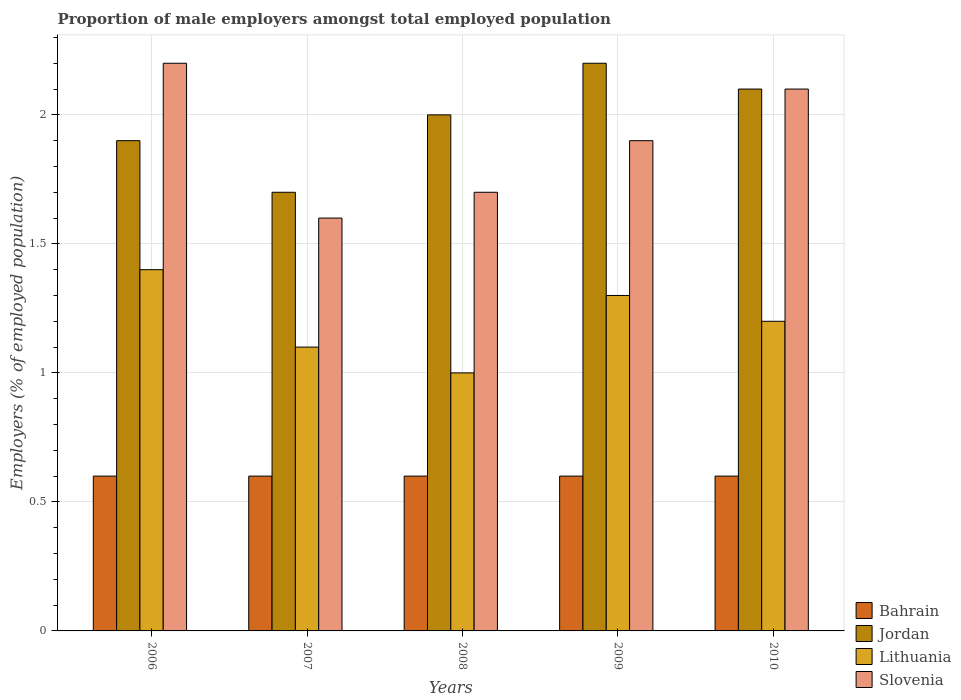How many bars are there on the 4th tick from the left?
Keep it short and to the point. 4. How many bars are there on the 3rd tick from the right?
Your response must be concise. 4. What is the proportion of male employers in Lithuania in 2006?
Give a very brief answer. 1.4. Across all years, what is the maximum proportion of male employers in Jordan?
Your answer should be compact. 2.2. Across all years, what is the minimum proportion of male employers in Slovenia?
Offer a terse response. 1.6. In which year was the proportion of male employers in Bahrain maximum?
Provide a short and direct response. 2006. What is the difference between the proportion of male employers in Slovenia in 2007 and that in 2009?
Offer a terse response. -0.3. What is the difference between the proportion of male employers in Slovenia in 2008 and the proportion of male employers in Lithuania in 2009?
Provide a succinct answer. 0.4. What is the average proportion of male employers in Slovenia per year?
Offer a terse response. 1.9. In the year 2010, what is the difference between the proportion of male employers in Lithuania and proportion of male employers in Bahrain?
Ensure brevity in your answer.  0.6. In how many years, is the proportion of male employers in Bahrain greater than 2.2 %?
Offer a terse response. 0. Is the proportion of male employers in Slovenia in 2006 less than that in 2009?
Your response must be concise. No. Is the difference between the proportion of male employers in Lithuania in 2006 and 2007 greater than the difference between the proportion of male employers in Bahrain in 2006 and 2007?
Your response must be concise. Yes. What is the difference between the highest and the lowest proportion of male employers in Bahrain?
Keep it short and to the point. 0. In how many years, is the proportion of male employers in Lithuania greater than the average proportion of male employers in Lithuania taken over all years?
Your answer should be compact. 3. What does the 4th bar from the left in 2006 represents?
Provide a short and direct response. Slovenia. What does the 3rd bar from the right in 2008 represents?
Provide a short and direct response. Jordan. Are all the bars in the graph horizontal?
Ensure brevity in your answer.  No. How many years are there in the graph?
Provide a short and direct response. 5. What is the difference between two consecutive major ticks on the Y-axis?
Provide a succinct answer. 0.5. Does the graph contain any zero values?
Make the answer very short. No. Does the graph contain grids?
Give a very brief answer. Yes. Where does the legend appear in the graph?
Offer a very short reply. Bottom right. How many legend labels are there?
Your response must be concise. 4. How are the legend labels stacked?
Make the answer very short. Vertical. What is the title of the graph?
Make the answer very short. Proportion of male employers amongst total employed population. What is the label or title of the Y-axis?
Your answer should be compact. Employers (% of employed population). What is the Employers (% of employed population) of Bahrain in 2006?
Offer a very short reply. 0.6. What is the Employers (% of employed population) in Jordan in 2006?
Your response must be concise. 1.9. What is the Employers (% of employed population) of Lithuania in 2006?
Offer a very short reply. 1.4. What is the Employers (% of employed population) of Slovenia in 2006?
Keep it short and to the point. 2.2. What is the Employers (% of employed population) of Bahrain in 2007?
Your response must be concise. 0.6. What is the Employers (% of employed population) in Jordan in 2007?
Provide a short and direct response. 1.7. What is the Employers (% of employed population) in Lithuania in 2007?
Provide a short and direct response. 1.1. What is the Employers (% of employed population) in Slovenia in 2007?
Provide a short and direct response. 1.6. What is the Employers (% of employed population) in Bahrain in 2008?
Offer a terse response. 0.6. What is the Employers (% of employed population) in Jordan in 2008?
Give a very brief answer. 2. What is the Employers (% of employed population) in Lithuania in 2008?
Make the answer very short. 1. What is the Employers (% of employed population) in Slovenia in 2008?
Provide a succinct answer. 1.7. What is the Employers (% of employed population) in Bahrain in 2009?
Offer a very short reply. 0.6. What is the Employers (% of employed population) in Jordan in 2009?
Provide a short and direct response. 2.2. What is the Employers (% of employed population) of Lithuania in 2009?
Keep it short and to the point. 1.3. What is the Employers (% of employed population) of Slovenia in 2009?
Provide a short and direct response. 1.9. What is the Employers (% of employed population) in Bahrain in 2010?
Ensure brevity in your answer.  0.6. What is the Employers (% of employed population) of Jordan in 2010?
Your response must be concise. 2.1. What is the Employers (% of employed population) of Lithuania in 2010?
Give a very brief answer. 1.2. What is the Employers (% of employed population) of Slovenia in 2010?
Provide a short and direct response. 2.1. Across all years, what is the maximum Employers (% of employed population) of Bahrain?
Provide a succinct answer. 0.6. Across all years, what is the maximum Employers (% of employed population) of Jordan?
Keep it short and to the point. 2.2. Across all years, what is the maximum Employers (% of employed population) in Lithuania?
Provide a short and direct response. 1.4. Across all years, what is the maximum Employers (% of employed population) in Slovenia?
Your answer should be compact. 2.2. Across all years, what is the minimum Employers (% of employed population) in Bahrain?
Ensure brevity in your answer.  0.6. Across all years, what is the minimum Employers (% of employed population) of Jordan?
Your answer should be very brief. 1.7. Across all years, what is the minimum Employers (% of employed population) of Lithuania?
Give a very brief answer. 1. Across all years, what is the minimum Employers (% of employed population) in Slovenia?
Keep it short and to the point. 1.6. What is the total Employers (% of employed population) of Jordan in the graph?
Give a very brief answer. 9.9. What is the total Employers (% of employed population) of Lithuania in the graph?
Offer a very short reply. 6. What is the total Employers (% of employed population) in Slovenia in the graph?
Provide a short and direct response. 9.5. What is the difference between the Employers (% of employed population) in Bahrain in 2006 and that in 2007?
Make the answer very short. 0. What is the difference between the Employers (% of employed population) of Bahrain in 2006 and that in 2008?
Offer a terse response. 0. What is the difference between the Employers (% of employed population) in Lithuania in 2006 and that in 2008?
Provide a succinct answer. 0.4. What is the difference between the Employers (% of employed population) of Slovenia in 2006 and that in 2008?
Offer a very short reply. 0.5. What is the difference between the Employers (% of employed population) in Jordan in 2006 and that in 2009?
Offer a very short reply. -0.3. What is the difference between the Employers (% of employed population) of Slovenia in 2006 and that in 2009?
Provide a short and direct response. 0.3. What is the difference between the Employers (% of employed population) in Jordan in 2006 and that in 2010?
Your answer should be compact. -0.2. What is the difference between the Employers (% of employed population) in Lithuania in 2006 and that in 2010?
Provide a short and direct response. 0.2. What is the difference between the Employers (% of employed population) in Slovenia in 2006 and that in 2010?
Your answer should be very brief. 0.1. What is the difference between the Employers (% of employed population) in Bahrain in 2007 and that in 2009?
Make the answer very short. 0. What is the difference between the Employers (% of employed population) of Jordan in 2007 and that in 2009?
Give a very brief answer. -0.5. What is the difference between the Employers (% of employed population) of Bahrain in 2007 and that in 2010?
Your answer should be compact. 0. What is the difference between the Employers (% of employed population) of Jordan in 2007 and that in 2010?
Your answer should be compact. -0.4. What is the difference between the Employers (% of employed population) of Slovenia in 2007 and that in 2010?
Give a very brief answer. -0.5. What is the difference between the Employers (% of employed population) in Bahrain in 2008 and that in 2009?
Make the answer very short. 0. What is the difference between the Employers (% of employed population) of Jordan in 2008 and that in 2009?
Make the answer very short. -0.2. What is the difference between the Employers (% of employed population) of Slovenia in 2008 and that in 2009?
Make the answer very short. -0.2. What is the difference between the Employers (% of employed population) in Jordan in 2008 and that in 2010?
Offer a very short reply. -0.1. What is the difference between the Employers (% of employed population) in Lithuania in 2008 and that in 2010?
Make the answer very short. -0.2. What is the difference between the Employers (% of employed population) of Slovenia in 2008 and that in 2010?
Make the answer very short. -0.4. What is the difference between the Employers (% of employed population) of Bahrain in 2009 and that in 2010?
Offer a very short reply. 0. What is the difference between the Employers (% of employed population) in Lithuania in 2009 and that in 2010?
Keep it short and to the point. 0.1. What is the difference between the Employers (% of employed population) of Bahrain in 2006 and the Employers (% of employed population) of Lithuania in 2007?
Your answer should be compact. -0.5. What is the difference between the Employers (% of employed population) of Bahrain in 2006 and the Employers (% of employed population) of Slovenia in 2007?
Provide a succinct answer. -1. What is the difference between the Employers (% of employed population) in Jordan in 2006 and the Employers (% of employed population) in Lithuania in 2007?
Make the answer very short. 0.8. What is the difference between the Employers (% of employed population) of Jordan in 2006 and the Employers (% of employed population) of Slovenia in 2007?
Your answer should be compact. 0.3. What is the difference between the Employers (% of employed population) of Bahrain in 2006 and the Employers (% of employed population) of Jordan in 2008?
Provide a short and direct response. -1.4. What is the difference between the Employers (% of employed population) of Jordan in 2006 and the Employers (% of employed population) of Lithuania in 2008?
Give a very brief answer. 0.9. What is the difference between the Employers (% of employed population) in Jordan in 2006 and the Employers (% of employed population) in Slovenia in 2008?
Your response must be concise. 0.2. What is the difference between the Employers (% of employed population) of Bahrain in 2006 and the Employers (% of employed population) of Slovenia in 2009?
Keep it short and to the point. -1.3. What is the difference between the Employers (% of employed population) of Jordan in 2006 and the Employers (% of employed population) of Lithuania in 2009?
Your answer should be very brief. 0.6. What is the difference between the Employers (% of employed population) of Jordan in 2006 and the Employers (% of employed population) of Slovenia in 2009?
Your response must be concise. 0. What is the difference between the Employers (% of employed population) in Bahrain in 2006 and the Employers (% of employed population) in Jordan in 2010?
Offer a terse response. -1.5. What is the difference between the Employers (% of employed population) in Bahrain in 2006 and the Employers (% of employed population) in Lithuania in 2010?
Your answer should be very brief. -0.6. What is the difference between the Employers (% of employed population) in Bahrain in 2007 and the Employers (% of employed population) in Jordan in 2008?
Make the answer very short. -1.4. What is the difference between the Employers (% of employed population) of Jordan in 2007 and the Employers (% of employed population) of Slovenia in 2008?
Ensure brevity in your answer.  0. What is the difference between the Employers (% of employed population) in Bahrain in 2007 and the Employers (% of employed population) in Slovenia in 2009?
Offer a very short reply. -1.3. What is the difference between the Employers (% of employed population) in Bahrain in 2007 and the Employers (% of employed population) in Jordan in 2010?
Provide a succinct answer. -1.5. What is the difference between the Employers (% of employed population) of Bahrain in 2007 and the Employers (% of employed population) of Lithuania in 2010?
Offer a terse response. -0.6. What is the difference between the Employers (% of employed population) in Bahrain in 2007 and the Employers (% of employed population) in Slovenia in 2010?
Give a very brief answer. -1.5. What is the difference between the Employers (% of employed population) of Jordan in 2007 and the Employers (% of employed population) of Lithuania in 2010?
Ensure brevity in your answer.  0.5. What is the difference between the Employers (% of employed population) of Lithuania in 2007 and the Employers (% of employed population) of Slovenia in 2010?
Keep it short and to the point. -1. What is the difference between the Employers (% of employed population) in Bahrain in 2008 and the Employers (% of employed population) in Slovenia in 2009?
Your answer should be very brief. -1.3. What is the difference between the Employers (% of employed population) of Jordan in 2008 and the Employers (% of employed population) of Lithuania in 2009?
Your answer should be very brief. 0.7. What is the difference between the Employers (% of employed population) in Jordan in 2008 and the Employers (% of employed population) in Slovenia in 2009?
Give a very brief answer. 0.1. What is the difference between the Employers (% of employed population) of Bahrain in 2008 and the Employers (% of employed population) of Jordan in 2010?
Offer a terse response. -1.5. What is the difference between the Employers (% of employed population) of Bahrain in 2008 and the Employers (% of employed population) of Slovenia in 2010?
Your response must be concise. -1.5. What is the difference between the Employers (% of employed population) in Jordan in 2008 and the Employers (% of employed population) in Slovenia in 2010?
Provide a short and direct response. -0.1. What is the difference between the Employers (% of employed population) in Lithuania in 2008 and the Employers (% of employed population) in Slovenia in 2010?
Offer a very short reply. -1.1. What is the difference between the Employers (% of employed population) of Bahrain in 2009 and the Employers (% of employed population) of Jordan in 2010?
Provide a succinct answer. -1.5. What is the difference between the Employers (% of employed population) of Bahrain in 2009 and the Employers (% of employed population) of Slovenia in 2010?
Provide a succinct answer. -1.5. What is the difference between the Employers (% of employed population) in Jordan in 2009 and the Employers (% of employed population) in Lithuania in 2010?
Your answer should be very brief. 1. What is the difference between the Employers (% of employed population) in Jordan in 2009 and the Employers (% of employed population) in Slovenia in 2010?
Provide a short and direct response. 0.1. What is the average Employers (% of employed population) of Bahrain per year?
Keep it short and to the point. 0.6. What is the average Employers (% of employed population) in Jordan per year?
Make the answer very short. 1.98. In the year 2006, what is the difference between the Employers (% of employed population) in Bahrain and Employers (% of employed population) in Lithuania?
Provide a succinct answer. -0.8. In the year 2006, what is the difference between the Employers (% of employed population) in Bahrain and Employers (% of employed population) in Slovenia?
Keep it short and to the point. -1.6. In the year 2006, what is the difference between the Employers (% of employed population) in Jordan and Employers (% of employed population) in Slovenia?
Your answer should be very brief. -0.3. In the year 2007, what is the difference between the Employers (% of employed population) of Bahrain and Employers (% of employed population) of Lithuania?
Give a very brief answer. -0.5. In the year 2007, what is the difference between the Employers (% of employed population) of Jordan and Employers (% of employed population) of Slovenia?
Keep it short and to the point. 0.1. In the year 2008, what is the difference between the Employers (% of employed population) in Bahrain and Employers (% of employed population) in Jordan?
Provide a short and direct response. -1.4. In the year 2008, what is the difference between the Employers (% of employed population) in Bahrain and Employers (% of employed population) in Lithuania?
Offer a terse response. -0.4. In the year 2008, what is the difference between the Employers (% of employed population) of Lithuania and Employers (% of employed population) of Slovenia?
Keep it short and to the point. -0.7. In the year 2009, what is the difference between the Employers (% of employed population) in Bahrain and Employers (% of employed population) in Lithuania?
Offer a terse response. -0.7. In the year 2009, what is the difference between the Employers (% of employed population) of Bahrain and Employers (% of employed population) of Slovenia?
Offer a terse response. -1.3. In the year 2009, what is the difference between the Employers (% of employed population) of Lithuania and Employers (% of employed population) of Slovenia?
Ensure brevity in your answer.  -0.6. In the year 2010, what is the difference between the Employers (% of employed population) in Bahrain and Employers (% of employed population) in Lithuania?
Ensure brevity in your answer.  -0.6. In the year 2010, what is the difference between the Employers (% of employed population) in Bahrain and Employers (% of employed population) in Slovenia?
Give a very brief answer. -1.5. In the year 2010, what is the difference between the Employers (% of employed population) of Jordan and Employers (% of employed population) of Lithuania?
Provide a short and direct response. 0.9. In the year 2010, what is the difference between the Employers (% of employed population) of Jordan and Employers (% of employed population) of Slovenia?
Provide a succinct answer. 0. In the year 2010, what is the difference between the Employers (% of employed population) of Lithuania and Employers (% of employed population) of Slovenia?
Offer a terse response. -0.9. What is the ratio of the Employers (% of employed population) of Bahrain in 2006 to that in 2007?
Keep it short and to the point. 1. What is the ratio of the Employers (% of employed population) in Jordan in 2006 to that in 2007?
Your answer should be very brief. 1.12. What is the ratio of the Employers (% of employed population) in Lithuania in 2006 to that in 2007?
Provide a short and direct response. 1.27. What is the ratio of the Employers (% of employed population) in Slovenia in 2006 to that in 2007?
Offer a terse response. 1.38. What is the ratio of the Employers (% of employed population) of Slovenia in 2006 to that in 2008?
Give a very brief answer. 1.29. What is the ratio of the Employers (% of employed population) of Bahrain in 2006 to that in 2009?
Give a very brief answer. 1. What is the ratio of the Employers (% of employed population) in Jordan in 2006 to that in 2009?
Ensure brevity in your answer.  0.86. What is the ratio of the Employers (% of employed population) of Lithuania in 2006 to that in 2009?
Keep it short and to the point. 1.08. What is the ratio of the Employers (% of employed population) in Slovenia in 2006 to that in 2009?
Offer a very short reply. 1.16. What is the ratio of the Employers (% of employed population) of Bahrain in 2006 to that in 2010?
Ensure brevity in your answer.  1. What is the ratio of the Employers (% of employed population) of Jordan in 2006 to that in 2010?
Provide a succinct answer. 0.9. What is the ratio of the Employers (% of employed population) in Lithuania in 2006 to that in 2010?
Ensure brevity in your answer.  1.17. What is the ratio of the Employers (% of employed population) of Slovenia in 2006 to that in 2010?
Give a very brief answer. 1.05. What is the ratio of the Employers (% of employed population) of Bahrain in 2007 to that in 2008?
Your answer should be compact. 1. What is the ratio of the Employers (% of employed population) of Lithuania in 2007 to that in 2008?
Offer a very short reply. 1.1. What is the ratio of the Employers (% of employed population) in Slovenia in 2007 to that in 2008?
Your response must be concise. 0.94. What is the ratio of the Employers (% of employed population) of Jordan in 2007 to that in 2009?
Give a very brief answer. 0.77. What is the ratio of the Employers (% of employed population) of Lithuania in 2007 to that in 2009?
Keep it short and to the point. 0.85. What is the ratio of the Employers (% of employed population) in Slovenia in 2007 to that in 2009?
Give a very brief answer. 0.84. What is the ratio of the Employers (% of employed population) of Jordan in 2007 to that in 2010?
Provide a short and direct response. 0.81. What is the ratio of the Employers (% of employed population) of Slovenia in 2007 to that in 2010?
Offer a terse response. 0.76. What is the ratio of the Employers (% of employed population) in Lithuania in 2008 to that in 2009?
Ensure brevity in your answer.  0.77. What is the ratio of the Employers (% of employed population) in Slovenia in 2008 to that in 2009?
Provide a succinct answer. 0.89. What is the ratio of the Employers (% of employed population) of Jordan in 2008 to that in 2010?
Your answer should be compact. 0.95. What is the ratio of the Employers (% of employed population) in Lithuania in 2008 to that in 2010?
Your answer should be compact. 0.83. What is the ratio of the Employers (% of employed population) in Slovenia in 2008 to that in 2010?
Give a very brief answer. 0.81. What is the ratio of the Employers (% of employed population) in Jordan in 2009 to that in 2010?
Your answer should be very brief. 1.05. What is the ratio of the Employers (% of employed population) of Lithuania in 2009 to that in 2010?
Ensure brevity in your answer.  1.08. What is the ratio of the Employers (% of employed population) in Slovenia in 2009 to that in 2010?
Give a very brief answer. 0.9. What is the difference between the highest and the second highest Employers (% of employed population) of Bahrain?
Keep it short and to the point. 0. What is the difference between the highest and the lowest Employers (% of employed population) of Lithuania?
Your answer should be very brief. 0.4. 